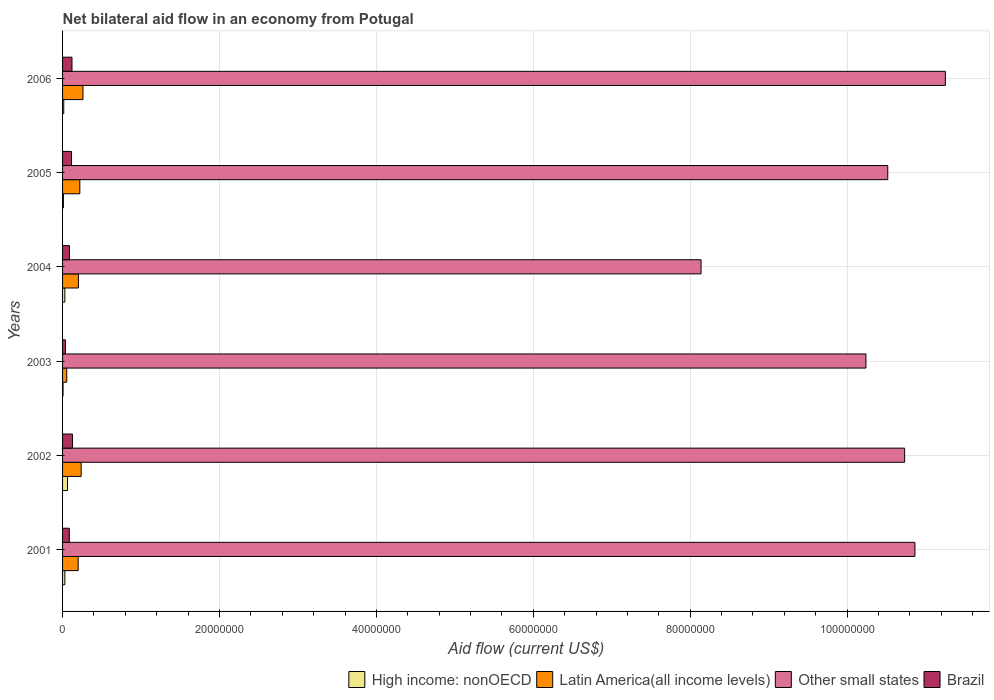Are the number of bars on each tick of the Y-axis equal?
Offer a very short reply. Yes. How many bars are there on the 4th tick from the top?
Offer a very short reply. 4. How many bars are there on the 3rd tick from the bottom?
Keep it short and to the point. 4. Across all years, what is the maximum net bilateral aid flow in Other small states?
Offer a terse response. 1.13e+08. Across all years, what is the minimum net bilateral aid flow in Other small states?
Offer a terse response. 8.14e+07. What is the total net bilateral aid flow in Brazil in the graph?
Ensure brevity in your answer.  5.72e+06. What is the difference between the net bilateral aid flow in Brazil in 2002 and that in 2005?
Your answer should be very brief. 1.30e+05. What is the difference between the net bilateral aid flow in Other small states in 2006 and the net bilateral aid flow in Latin America(all income levels) in 2005?
Offer a very short reply. 1.10e+08. What is the average net bilateral aid flow in Latin America(all income levels) per year?
Make the answer very short. 1.95e+06. In the year 2003, what is the difference between the net bilateral aid flow in High income: nonOECD and net bilateral aid flow in Latin America(all income levels)?
Offer a very short reply. -4.70e+05. In how many years, is the net bilateral aid flow in Other small states greater than 8000000 US$?
Provide a succinct answer. 6. What is the ratio of the net bilateral aid flow in High income: nonOECD in 2001 to that in 2002?
Make the answer very short. 0.46. Is the net bilateral aid flow in Latin America(all income levels) in 2003 less than that in 2006?
Your response must be concise. Yes. Is the difference between the net bilateral aid flow in High income: nonOECD in 2001 and 2002 greater than the difference between the net bilateral aid flow in Latin America(all income levels) in 2001 and 2002?
Your answer should be compact. Yes. What is the difference between the highest and the lowest net bilateral aid flow in High income: nonOECD?
Give a very brief answer. 5.70e+05. In how many years, is the net bilateral aid flow in Brazil greater than the average net bilateral aid flow in Brazil taken over all years?
Make the answer very short. 3. Is the sum of the net bilateral aid flow in Other small states in 2002 and 2006 greater than the maximum net bilateral aid flow in High income: nonOECD across all years?
Keep it short and to the point. Yes. What does the 3rd bar from the bottom in 2003 represents?
Offer a very short reply. Other small states. Is it the case that in every year, the sum of the net bilateral aid flow in Latin America(all income levels) and net bilateral aid flow in Brazil is greater than the net bilateral aid flow in Other small states?
Your answer should be very brief. No. Are all the bars in the graph horizontal?
Your response must be concise. Yes. How many years are there in the graph?
Give a very brief answer. 6. What is the difference between two consecutive major ticks on the X-axis?
Offer a very short reply. 2.00e+07. Where does the legend appear in the graph?
Your response must be concise. Bottom right. How are the legend labels stacked?
Offer a very short reply. Horizontal. What is the title of the graph?
Provide a short and direct response. Net bilateral aid flow in an economy from Potugal. Does "Mozambique" appear as one of the legend labels in the graph?
Your answer should be very brief. No. What is the label or title of the X-axis?
Ensure brevity in your answer.  Aid flow (current US$). What is the Aid flow (current US$) of Latin America(all income levels) in 2001?
Your answer should be very brief. 1.99e+06. What is the Aid flow (current US$) in Other small states in 2001?
Provide a succinct answer. 1.09e+08. What is the Aid flow (current US$) in Brazil in 2001?
Ensure brevity in your answer.  8.60e+05. What is the Aid flow (current US$) of High income: nonOECD in 2002?
Your answer should be compact. 6.30e+05. What is the Aid flow (current US$) in Latin America(all income levels) in 2002?
Give a very brief answer. 2.37e+06. What is the Aid flow (current US$) of Other small states in 2002?
Ensure brevity in your answer.  1.07e+08. What is the Aid flow (current US$) of Brazil in 2002?
Offer a very short reply. 1.27e+06. What is the Aid flow (current US$) in High income: nonOECD in 2003?
Provide a succinct answer. 6.00e+04. What is the Aid flow (current US$) of Latin America(all income levels) in 2003?
Provide a short and direct response. 5.30e+05. What is the Aid flow (current US$) in Other small states in 2003?
Give a very brief answer. 1.02e+08. What is the Aid flow (current US$) in High income: nonOECD in 2004?
Ensure brevity in your answer.  2.90e+05. What is the Aid flow (current US$) of Latin America(all income levels) in 2004?
Ensure brevity in your answer.  2.02e+06. What is the Aid flow (current US$) of Other small states in 2004?
Give a very brief answer. 8.14e+07. What is the Aid flow (current US$) of Brazil in 2004?
Offer a very short reply. 8.80e+05. What is the Aid flow (current US$) of Latin America(all income levels) in 2005?
Provide a succinct answer. 2.20e+06. What is the Aid flow (current US$) in Other small states in 2005?
Ensure brevity in your answer.  1.05e+08. What is the Aid flow (current US$) of Brazil in 2005?
Your answer should be compact. 1.14e+06. What is the Aid flow (current US$) in Latin America(all income levels) in 2006?
Give a very brief answer. 2.60e+06. What is the Aid flow (current US$) of Other small states in 2006?
Make the answer very short. 1.13e+08. What is the Aid flow (current US$) of Brazil in 2006?
Offer a terse response. 1.20e+06. Across all years, what is the maximum Aid flow (current US$) of High income: nonOECD?
Your response must be concise. 6.30e+05. Across all years, what is the maximum Aid flow (current US$) of Latin America(all income levels)?
Offer a terse response. 2.60e+06. Across all years, what is the maximum Aid flow (current US$) in Other small states?
Your answer should be compact. 1.13e+08. Across all years, what is the maximum Aid flow (current US$) of Brazil?
Give a very brief answer. 1.27e+06. Across all years, what is the minimum Aid flow (current US$) in Latin America(all income levels)?
Offer a terse response. 5.30e+05. Across all years, what is the minimum Aid flow (current US$) of Other small states?
Ensure brevity in your answer.  8.14e+07. What is the total Aid flow (current US$) of High income: nonOECD in the graph?
Ensure brevity in your answer.  1.53e+06. What is the total Aid flow (current US$) of Latin America(all income levels) in the graph?
Your answer should be very brief. 1.17e+07. What is the total Aid flow (current US$) of Other small states in the graph?
Provide a short and direct response. 6.17e+08. What is the total Aid flow (current US$) in Brazil in the graph?
Offer a terse response. 5.72e+06. What is the difference between the Aid flow (current US$) in Latin America(all income levels) in 2001 and that in 2002?
Give a very brief answer. -3.80e+05. What is the difference between the Aid flow (current US$) of Other small states in 2001 and that in 2002?
Keep it short and to the point. 1.31e+06. What is the difference between the Aid flow (current US$) of Brazil in 2001 and that in 2002?
Offer a terse response. -4.10e+05. What is the difference between the Aid flow (current US$) of Latin America(all income levels) in 2001 and that in 2003?
Your response must be concise. 1.46e+06. What is the difference between the Aid flow (current US$) of Other small states in 2001 and that in 2003?
Offer a terse response. 6.24e+06. What is the difference between the Aid flow (current US$) of Brazil in 2001 and that in 2003?
Your response must be concise. 4.90e+05. What is the difference between the Aid flow (current US$) in High income: nonOECD in 2001 and that in 2004?
Make the answer very short. 0. What is the difference between the Aid flow (current US$) of Other small states in 2001 and that in 2004?
Offer a very short reply. 2.73e+07. What is the difference between the Aid flow (current US$) in Other small states in 2001 and that in 2005?
Offer a terse response. 3.46e+06. What is the difference between the Aid flow (current US$) of Brazil in 2001 and that in 2005?
Provide a short and direct response. -2.80e+05. What is the difference between the Aid flow (current US$) of Latin America(all income levels) in 2001 and that in 2006?
Ensure brevity in your answer.  -6.10e+05. What is the difference between the Aid flow (current US$) of Other small states in 2001 and that in 2006?
Keep it short and to the point. -3.88e+06. What is the difference between the Aid flow (current US$) in Brazil in 2001 and that in 2006?
Provide a succinct answer. -3.40e+05. What is the difference between the Aid flow (current US$) in High income: nonOECD in 2002 and that in 2003?
Keep it short and to the point. 5.70e+05. What is the difference between the Aid flow (current US$) of Latin America(all income levels) in 2002 and that in 2003?
Provide a succinct answer. 1.84e+06. What is the difference between the Aid flow (current US$) in Other small states in 2002 and that in 2003?
Offer a terse response. 4.93e+06. What is the difference between the Aid flow (current US$) in High income: nonOECD in 2002 and that in 2004?
Keep it short and to the point. 3.40e+05. What is the difference between the Aid flow (current US$) of Other small states in 2002 and that in 2004?
Provide a short and direct response. 2.60e+07. What is the difference between the Aid flow (current US$) in High income: nonOECD in 2002 and that in 2005?
Ensure brevity in your answer.  5.20e+05. What is the difference between the Aid flow (current US$) in Latin America(all income levels) in 2002 and that in 2005?
Make the answer very short. 1.70e+05. What is the difference between the Aid flow (current US$) of Other small states in 2002 and that in 2005?
Offer a very short reply. 2.15e+06. What is the difference between the Aid flow (current US$) in Brazil in 2002 and that in 2005?
Provide a succinct answer. 1.30e+05. What is the difference between the Aid flow (current US$) in Other small states in 2002 and that in 2006?
Make the answer very short. -5.19e+06. What is the difference between the Aid flow (current US$) of Brazil in 2002 and that in 2006?
Offer a terse response. 7.00e+04. What is the difference between the Aid flow (current US$) in Latin America(all income levels) in 2003 and that in 2004?
Your answer should be very brief. -1.49e+06. What is the difference between the Aid flow (current US$) of Other small states in 2003 and that in 2004?
Your response must be concise. 2.10e+07. What is the difference between the Aid flow (current US$) in Brazil in 2003 and that in 2004?
Ensure brevity in your answer.  -5.10e+05. What is the difference between the Aid flow (current US$) of High income: nonOECD in 2003 and that in 2005?
Your answer should be compact. -5.00e+04. What is the difference between the Aid flow (current US$) of Latin America(all income levels) in 2003 and that in 2005?
Keep it short and to the point. -1.67e+06. What is the difference between the Aid flow (current US$) in Other small states in 2003 and that in 2005?
Provide a succinct answer. -2.78e+06. What is the difference between the Aid flow (current US$) of Brazil in 2003 and that in 2005?
Your response must be concise. -7.70e+05. What is the difference between the Aid flow (current US$) in Latin America(all income levels) in 2003 and that in 2006?
Your answer should be very brief. -2.07e+06. What is the difference between the Aid flow (current US$) of Other small states in 2003 and that in 2006?
Keep it short and to the point. -1.01e+07. What is the difference between the Aid flow (current US$) of Brazil in 2003 and that in 2006?
Your response must be concise. -8.30e+05. What is the difference between the Aid flow (current US$) in High income: nonOECD in 2004 and that in 2005?
Your answer should be very brief. 1.80e+05. What is the difference between the Aid flow (current US$) of Latin America(all income levels) in 2004 and that in 2005?
Make the answer very short. -1.80e+05. What is the difference between the Aid flow (current US$) of Other small states in 2004 and that in 2005?
Make the answer very short. -2.38e+07. What is the difference between the Aid flow (current US$) in Brazil in 2004 and that in 2005?
Keep it short and to the point. -2.60e+05. What is the difference between the Aid flow (current US$) of Latin America(all income levels) in 2004 and that in 2006?
Offer a very short reply. -5.80e+05. What is the difference between the Aid flow (current US$) of Other small states in 2004 and that in 2006?
Provide a short and direct response. -3.11e+07. What is the difference between the Aid flow (current US$) in Brazil in 2004 and that in 2006?
Offer a very short reply. -3.20e+05. What is the difference between the Aid flow (current US$) of Latin America(all income levels) in 2005 and that in 2006?
Make the answer very short. -4.00e+05. What is the difference between the Aid flow (current US$) of Other small states in 2005 and that in 2006?
Your answer should be compact. -7.34e+06. What is the difference between the Aid flow (current US$) of High income: nonOECD in 2001 and the Aid flow (current US$) of Latin America(all income levels) in 2002?
Provide a short and direct response. -2.08e+06. What is the difference between the Aid flow (current US$) of High income: nonOECD in 2001 and the Aid flow (current US$) of Other small states in 2002?
Your answer should be compact. -1.07e+08. What is the difference between the Aid flow (current US$) in High income: nonOECD in 2001 and the Aid flow (current US$) in Brazil in 2002?
Provide a short and direct response. -9.80e+05. What is the difference between the Aid flow (current US$) of Latin America(all income levels) in 2001 and the Aid flow (current US$) of Other small states in 2002?
Provide a succinct answer. -1.05e+08. What is the difference between the Aid flow (current US$) of Latin America(all income levels) in 2001 and the Aid flow (current US$) of Brazil in 2002?
Keep it short and to the point. 7.20e+05. What is the difference between the Aid flow (current US$) in Other small states in 2001 and the Aid flow (current US$) in Brazil in 2002?
Ensure brevity in your answer.  1.07e+08. What is the difference between the Aid flow (current US$) of High income: nonOECD in 2001 and the Aid flow (current US$) of Other small states in 2003?
Provide a succinct answer. -1.02e+08. What is the difference between the Aid flow (current US$) in Latin America(all income levels) in 2001 and the Aid flow (current US$) in Other small states in 2003?
Your response must be concise. -1.00e+08. What is the difference between the Aid flow (current US$) of Latin America(all income levels) in 2001 and the Aid flow (current US$) of Brazil in 2003?
Offer a terse response. 1.62e+06. What is the difference between the Aid flow (current US$) of Other small states in 2001 and the Aid flow (current US$) of Brazil in 2003?
Keep it short and to the point. 1.08e+08. What is the difference between the Aid flow (current US$) of High income: nonOECD in 2001 and the Aid flow (current US$) of Latin America(all income levels) in 2004?
Keep it short and to the point. -1.73e+06. What is the difference between the Aid flow (current US$) of High income: nonOECD in 2001 and the Aid flow (current US$) of Other small states in 2004?
Your answer should be very brief. -8.11e+07. What is the difference between the Aid flow (current US$) of High income: nonOECD in 2001 and the Aid flow (current US$) of Brazil in 2004?
Offer a terse response. -5.90e+05. What is the difference between the Aid flow (current US$) of Latin America(all income levels) in 2001 and the Aid flow (current US$) of Other small states in 2004?
Give a very brief answer. -7.94e+07. What is the difference between the Aid flow (current US$) in Latin America(all income levels) in 2001 and the Aid flow (current US$) in Brazil in 2004?
Provide a short and direct response. 1.11e+06. What is the difference between the Aid flow (current US$) in Other small states in 2001 and the Aid flow (current US$) in Brazil in 2004?
Your answer should be very brief. 1.08e+08. What is the difference between the Aid flow (current US$) of High income: nonOECD in 2001 and the Aid flow (current US$) of Latin America(all income levels) in 2005?
Your answer should be very brief. -1.91e+06. What is the difference between the Aid flow (current US$) of High income: nonOECD in 2001 and the Aid flow (current US$) of Other small states in 2005?
Your answer should be very brief. -1.05e+08. What is the difference between the Aid flow (current US$) of High income: nonOECD in 2001 and the Aid flow (current US$) of Brazil in 2005?
Offer a terse response. -8.50e+05. What is the difference between the Aid flow (current US$) in Latin America(all income levels) in 2001 and the Aid flow (current US$) in Other small states in 2005?
Provide a short and direct response. -1.03e+08. What is the difference between the Aid flow (current US$) in Latin America(all income levels) in 2001 and the Aid flow (current US$) in Brazil in 2005?
Provide a short and direct response. 8.50e+05. What is the difference between the Aid flow (current US$) of Other small states in 2001 and the Aid flow (current US$) of Brazil in 2005?
Provide a short and direct response. 1.08e+08. What is the difference between the Aid flow (current US$) of High income: nonOECD in 2001 and the Aid flow (current US$) of Latin America(all income levels) in 2006?
Keep it short and to the point. -2.31e+06. What is the difference between the Aid flow (current US$) of High income: nonOECD in 2001 and the Aid flow (current US$) of Other small states in 2006?
Provide a short and direct response. -1.12e+08. What is the difference between the Aid flow (current US$) in High income: nonOECD in 2001 and the Aid flow (current US$) in Brazil in 2006?
Provide a short and direct response. -9.10e+05. What is the difference between the Aid flow (current US$) in Latin America(all income levels) in 2001 and the Aid flow (current US$) in Other small states in 2006?
Provide a succinct answer. -1.11e+08. What is the difference between the Aid flow (current US$) in Latin America(all income levels) in 2001 and the Aid flow (current US$) in Brazil in 2006?
Offer a terse response. 7.90e+05. What is the difference between the Aid flow (current US$) of Other small states in 2001 and the Aid flow (current US$) of Brazil in 2006?
Make the answer very short. 1.07e+08. What is the difference between the Aid flow (current US$) in High income: nonOECD in 2002 and the Aid flow (current US$) in Latin America(all income levels) in 2003?
Your response must be concise. 1.00e+05. What is the difference between the Aid flow (current US$) in High income: nonOECD in 2002 and the Aid flow (current US$) in Other small states in 2003?
Your answer should be very brief. -1.02e+08. What is the difference between the Aid flow (current US$) of High income: nonOECD in 2002 and the Aid flow (current US$) of Brazil in 2003?
Ensure brevity in your answer.  2.60e+05. What is the difference between the Aid flow (current US$) of Latin America(all income levels) in 2002 and the Aid flow (current US$) of Other small states in 2003?
Your answer should be compact. -1.00e+08. What is the difference between the Aid flow (current US$) in Other small states in 2002 and the Aid flow (current US$) in Brazil in 2003?
Your response must be concise. 1.07e+08. What is the difference between the Aid flow (current US$) in High income: nonOECD in 2002 and the Aid flow (current US$) in Latin America(all income levels) in 2004?
Keep it short and to the point. -1.39e+06. What is the difference between the Aid flow (current US$) of High income: nonOECD in 2002 and the Aid flow (current US$) of Other small states in 2004?
Keep it short and to the point. -8.08e+07. What is the difference between the Aid flow (current US$) of High income: nonOECD in 2002 and the Aid flow (current US$) of Brazil in 2004?
Provide a succinct answer. -2.50e+05. What is the difference between the Aid flow (current US$) of Latin America(all income levels) in 2002 and the Aid flow (current US$) of Other small states in 2004?
Offer a very short reply. -7.90e+07. What is the difference between the Aid flow (current US$) of Latin America(all income levels) in 2002 and the Aid flow (current US$) of Brazil in 2004?
Offer a terse response. 1.49e+06. What is the difference between the Aid flow (current US$) of Other small states in 2002 and the Aid flow (current US$) of Brazil in 2004?
Make the answer very short. 1.06e+08. What is the difference between the Aid flow (current US$) of High income: nonOECD in 2002 and the Aid flow (current US$) of Latin America(all income levels) in 2005?
Give a very brief answer. -1.57e+06. What is the difference between the Aid flow (current US$) in High income: nonOECD in 2002 and the Aid flow (current US$) in Other small states in 2005?
Ensure brevity in your answer.  -1.05e+08. What is the difference between the Aid flow (current US$) of High income: nonOECD in 2002 and the Aid flow (current US$) of Brazil in 2005?
Your answer should be very brief. -5.10e+05. What is the difference between the Aid flow (current US$) in Latin America(all income levels) in 2002 and the Aid flow (current US$) in Other small states in 2005?
Provide a succinct answer. -1.03e+08. What is the difference between the Aid flow (current US$) in Latin America(all income levels) in 2002 and the Aid flow (current US$) in Brazil in 2005?
Your answer should be compact. 1.23e+06. What is the difference between the Aid flow (current US$) of Other small states in 2002 and the Aid flow (current US$) of Brazil in 2005?
Your response must be concise. 1.06e+08. What is the difference between the Aid flow (current US$) in High income: nonOECD in 2002 and the Aid flow (current US$) in Latin America(all income levels) in 2006?
Offer a terse response. -1.97e+06. What is the difference between the Aid flow (current US$) in High income: nonOECD in 2002 and the Aid flow (current US$) in Other small states in 2006?
Ensure brevity in your answer.  -1.12e+08. What is the difference between the Aid flow (current US$) in High income: nonOECD in 2002 and the Aid flow (current US$) in Brazil in 2006?
Offer a very short reply. -5.70e+05. What is the difference between the Aid flow (current US$) in Latin America(all income levels) in 2002 and the Aid flow (current US$) in Other small states in 2006?
Make the answer very short. -1.10e+08. What is the difference between the Aid flow (current US$) in Latin America(all income levels) in 2002 and the Aid flow (current US$) in Brazil in 2006?
Offer a terse response. 1.17e+06. What is the difference between the Aid flow (current US$) of Other small states in 2002 and the Aid flow (current US$) of Brazil in 2006?
Offer a terse response. 1.06e+08. What is the difference between the Aid flow (current US$) in High income: nonOECD in 2003 and the Aid flow (current US$) in Latin America(all income levels) in 2004?
Offer a terse response. -1.96e+06. What is the difference between the Aid flow (current US$) of High income: nonOECD in 2003 and the Aid flow (current US$) of Other small states in 2004?
Provide a succinct answer. -8.13e+07. What is the difference between the Aid flow (current US$) in High income: nonOECD in 2003 and the Aid flow (current US$) in Brazil in 2004?
Your answer should be very brief. -8.20e+05. What is the difference between the Aid flow (current US$) in Latin America(all income levels) in 2003 and the Aid flow (current US$) in Other small states in 2004?
Ensure brevity in your answer.  -8.08e+07. What is the difference between the Aid flow (current US$) of Latin America(all income levels) in 2003 and the Aid flow (current US$) of Brazil in 2004?
Make the answer very short. -3.50e+05. What is the difference between the Aid flow (current US$) in Other small states in 2003 and the Aid flow (current US$) in Brazil in 2004?
Keep it short and to the point. 1.02e+08. What is the difference between the Aid flow (current US$) in High income: nonOECD in 2003 and the Aid flow (current US$) in Latin America(all income levels) in 2005?
Offer a very short reply. -2.14e+06. What is the difference between the Aid flow (current US$) in High income: nonOECD in 2003 and the Aid flow (current US$) in Other small states in 2005?
Provide a short and direct response. -1.05e+08. What is the difference between the Aid flow (current US$) of High income: nonOECD in 2003 and the Aid flow (current US$) of Brazil in 2005?
Offer a very short reply. -1.08e+06. What is the difference between the Aid flow (current US$) in Latin America(all income levels) in 2003 and the Aid flow (current US$) in Other small states in 2005?
Offer a very short reply. -1.05e+08. What is the difference between the Aid flow (current US$) of Latin America(all income levels) in 2003 and the Aid flow (current US$) of Brazil in 2005?
Provide a succinct answer. -6.10e+05. What is the difference between the Aid flow (current US$) in Other small states in 2003 and the Aid flow (current US$) in Brazil in 2005?
Ensure brevity in your answer.  1.01e+08. What is the difference between the Aid flow (current US$) in High income: nonOECD in 2003 and the Aid flow (current US$) in Latin America(all income levels) in 2006?
Your response must be concise. -2.54e+06. What is the difference between the Aid flow (current US$) in High income: nonOECD in 2003 and the Aid flow (current US$) in Other small states in 2006?
Make the answer very short. -1.12e+08. What is the difference between the Aid flow (current US$) of High income: nonOECD in 2003 and the Aid flow (current US$) of Brazil in 2006?
Make the answer very short. -1.14e+06. What is the difference between the Aid flow (current US$) in Latin America(all income levels) in 2003 and the Aid flow (current US$) in Other small states in 2006?
Offer a terse response. -1.12e+08. What is the difference between the Aid flow (current US$) in Latin America(all income levels) in 2003 and the Aid flow (current US$) in Brazil in 2006?
Your answer should be compact. -6.70e+05. What is the difference between the Aid flow (current US$) in Other small states in 2003 and the Aid flow (current US$) in Brazil in 2006?
Offer a terse response. 1.01e+08. What is the difference between the Aid flow (current US$) of High income: nonOECD in 2004 and the Aid flow (current US$) of Latin America(all income levels) in 2005?
Your answer should be compact. -1.91e+06. What is the difference between the Aid flow (current US$) of High income: nonOECD in 2004 and the Aid flow (current US$) of Other small states in 2005?
Your answer should be very brief. -1.05e+08. What is the difference between the Aid flow (current US$) of High income: nonOECD in 2004 and the Aid flow (current US$) of Brazil in 2005?
Your answer should be very brief. -8.50e+05. What is the difference between the Aid flow (current US$) of Latin America(all income levels) in 2004 and the Aid flow (current US$) of Other small states in 2005?
Your response must be concise. -1.03e+08. What is the difference between the Aid flow (current US$) of Latin America(all income levels) in 2004 and the Aid flow (current US$) of Brazil in 2005?
Your answer should be compact. 8.80e+05. What is the difference between the Aid flow (current US$) of Other small states in 2004 and the Aid flow (current US$) of Brazil in 2005?
Make the answer very short. 8.02e+07. What is the difference between the Aid flow (current US$) of High income: nonOECD in 2004 and the Aid flow (current US$) of Latin America(all income levels) in 2006?
Give a very brief answer. -2.31e+06. What is the difference between the Aid flow (current US$) in High income: nonOECD in 2004 and the Aid flow (current US$) in Other small states in 2006?
Make the answer very short. -1.12e+08. What is the difference between the Aid flow (current US$) in High income: nonOECD in 2004 and the Aid flow (current US$) in Brazil in 2006?
Provide a succinct answer. -9.10e+05. What is the difference between the Aid flow (current US$) in Latin America(all income levels) in 2004 and the Aid flow (current US$) in Other small states in 2006?
Ensure brevity in your answer.  -1.10e+08. What is the difference between the Aid flow (current US$) in Latin America(all income levels) in 2004 and the Aid flow (current US$) in Brazil in 2006?
Your answer should be very brief. 8.20e+05. What is the difference between the Aid flow (current US$) of Other small states in 2004 and the Aid flow (current US$) of Brazil in 2006?
Offer a very short reply. 8.02e+07. What is the difference between the Aid flow (current US$) in High income: nonOECD in 2005 and the Aid flow (current US$) in Latin America(all income levels) in 2006?
Offer a terse response. -2.49e+06. What is the difference between the Aid flow (current US$) of High income: nonOECD in 2005 and the Aid flow (current US$) of Other small states in 2006?
Make the answer very short. -1.12e+08. What is the difference between the Aid flow (current US$) of High income: nonOECD in 2005 and the Aid flow (current US$) of Brazil in 2006?
Your response must be concise. -1.09e+06. What is the difference between the Aid flow (current US$) in Latin America(all income levels) in 2005 and the Aid flow (current US$) in Other small states in 2006?
Your answer should be very brief. -1.10e+08. What is the difference between the Aid flow (current US$) in Latin America(all income levels) in 2005 and the Aid flow (current US$) in Brazil in 2006?
Ensure brevity in your answer.  1.00e+06. What is the difference between the Aid flow (current US$) in Other small states in 2005 and the Aid flow (current US$) in Brazil in 2006?
Make the answer very short. 1.04e+08. What is the average Aid flow (current US$) of High income: nonOECD per year?
Offer a very short reply. 2.55e+05. What is the average Aid flow (current US$) in Latin America(all income levels) per year?
Make the answer very short. 1.95e+06. What is the average Aid flow (current US$) in Other small states per year?
Keep it short and to the point. 1.03e+08. What is the average Aid flow (current US$) of Brazil per year?
Offer a very short reply. 9.53e+05. In the year 2001, what is the difference between the Aid flow (current US$) of High income: nonOECD and Aid flow (current US$) of Latin America(all income levels)?
Give a very brief answer. -1.70e+06. In the year 2001, what is the difference between the Aid flow (current US$) in High income: nonOECD and Aid flow (current US$) in Other small states?
Your answer should be compact. -1.08e+08. In the year 2001, what is the difference between the Aid flow (current US$) in High income: nonOECD and Aid flow (current US$) in Brazil?
Ensure brevity in your answer.  -5.70e+05. In the year 2001, what is the difference between the Aid flow (current US$) of Latin America(all income levels) and Aid flow (current US$) of Other small states?
Your response must be concise. -1.07e+08. In the year 2001, what is the difference between the Aid flow (current US$) of Latin America(all income levels) and Aid flow (current US$) of Brazil?
Give a very brief answer. 1.13e+06. In the year 2001, what is the difference between the Aid flow (current US$) in Other small states and Aid flow (current US$) in Brazil?
Ensure brevity in your answer.  1.08e+08. In the year 2002, what is the difference between the Aid flow (current US$) in High income: nonOECD and Aid flow (current US$) in Latin America(all income levels)?
Your answer should be compact. -1.74e+06. In the year 2002, what is the difference between the Aid flow (current US$) of High income: nonOECD and Aid flow (current US$) of Other small states?
Offer a very short reply. -1.07e+08. In the year 2002, what is the difference between the Aid flow (current US$) in High income: nonOECD and Aid flow (current US$) in Brazil?
Offer a very short reply. -6.40e+05. In the year 2002, what is the difference between the Aid flow (current US$) in Latin America(all income levels) and Aid flow (current US$) in Other small states?
Your answer should be compact. -1.05e+08. In the year 2002, what is the difference between the Aid flow (current US$) of Latin America(all income levels) and Aid flow (current US$) of Brazil?
Your answer should be very brief. 1.10e+06. In the year 2002, what is the difference between the Aid flow (current US$) in Other small states and Aid flow (current US$) in Brazil?
Offer a terse response. 1.06e+08. In the year 2003, what is the difference between the Aid flow (current US$) in High income: nonOECD and Aid flow (current US$) in Latin America(all income levels)?
Offer a very short reply. -4.70e+05. In the year 2003, what is the difference between the Aid flow (current US$) in High income: nonOECD and Aid flow (current US$) in Other small states?
Make the answer very short. -1.02e+08. In the year 2003, what is the difference between the Aid flow (current US$) in High income: nonOECD and Aid flow (current US$) in Brazil?
Your answer should be very brief. -3.10e+05. In the year 2003, what is the difference between the Aid flow (current US$) of Latin America(all income levels) and Aid flow (current US$) of Other small states?
Offer a terse response. -1.02e+08. In the year 2003, what is the difference between the Aid flow (current US$) in Other small states and Aid flow (current US$) in Brazil?
Ensure brevity in your answer.  1.02e+08. In the year 2004, what is the difference between the Aid flow (current US$) in High income: nonOECD and Aid flow (current US$) in Latin America(all income levels)?
Give a very brief answer. -1.73e+06. In the year 2004, what is the difference between the Aid flow (current US$) in High income: nonOECD and Aid flow (current US$) in Other small states?
Your answer should be very brief. -8.11e+07. In the year 2004, what is the difference between the Aid flow (current US$) of High income: nonOECD and Aid flow (current US$) of Brazil?
Offer a terse response. -5.90e+05. In the year 2004, what is the difference between the Aid flow (current US$) in Latin America(all income levels) and Aid flow (current US$) in Other small states?
Offer a terse response. -7.94e+07. In the year 2004, what is the difference between the Aid flow (current US$) in Latin America(all income levels) and Aid flow (current US$) in Brazil?
Provide a short and direct response. 1.14e+06. In the year 2004, what is the difference between the Aid flow (current US$) in Other small states and Aid flow (current US$) in Brazil?
Provide a short and direct response. 8.05e+07. In the year 2005, what is the difference between the Aid flow (current US$) of High income: nonOECD and Aid flow (current US$) of Latin America(all income levels)?
Your answer should be very brief. -2.09e+06. In the year 2005, what is the difference between the Aid flow (current US$) in High income: nonOECD and Aid flow (current US$) in Other small states?
Your answer should be very brief. -1.05e+08. In the year 2005, what is the difference between the Aid flow (current US$) in High income: nonOECD and Aid flow (current US$) in Brazil?
Your answer should be compact. -1.03e+06. In the year 2005, what is the difference between the Aid flow (current US$) in Latin America(all income levels) and Aid flow (current US$) in Other small states?
Your answer should be compact. -1.03e+08. In the year 2005, what is the difference between the Aid flow (current US$) of Latin America(all income levels) and Aid flow (current US$) of Brazil?
Your answer should be compact. 1.06e+06. In the year 2005, what is the difference between the Aid flow (current US$) of Other small states and Aid flow (current US$) of Brazil?
Make the answer very short. 1.04e+08. In the year 2006, what is the difference between the Aid flow (current US$) of High income: nonOECD and Aid flow (current US$) of Latin America(all income levels)?
Your response must be concise. -2.45e+06. In the year 2006, what is the difference between the Aid flow (current US$) of High income: nonOECD and Aid flow (current US$) of Other small states?
Your answer should be very brief. -1.12e+08. In the year 2006, what is the difference between the Aid flow (current US$) in High income: nonOECD and Aid flow (current US$) in Brazil?
Keep it short and to the point. -1.05e+06. In the year 2006, what is the difference between the Aid flow (current US$) of Latin America(all income levels) and Aid flow (current US$) of Other small states?
Make the answer very short. -1.10e+08. In the year 2006, what is the difference between the Aid flow (current US$) in Latin America(all income levels) and Aid flow (current US$) in Brazil?
Keep it short and to the point. 1.40e+06. In the year 2006, what is the difference between the Aid flow (current US$) of Other small states and Aid flow (current US$) of Brazil?
Your answer should be very brief. 1.11e+08. What is the ratio of the Aid flow (current US$) in High income: nonOECD in 2001 to that in 2002?
Offer a terse response. 0.46. What is the ratio of the Aid flow (current US$) in Latin America(all income levels) in 2001 to that in 2002?
Keep it short and to the point. 0.84. What is the ratio of the Aid flow (current US$) in Other small states in 2001 to that in 2002?
Your response must be concise. 1.01. What is the ratio of the Aid flow (current US$) in Brazil in 2001 to that in 2002?
Your answer should be very brief. 0.68. What is the ratio of the Aid flow (current US$) in High income: nonOECD in 2001 to that in 2003?
Ensure brevity in your answer.  4.83. What is the ratio of the Aid flow (current US$) in Latin America(all income levels) in 2001 to that in 2003?
Provide a short and direct response. 3.75. What is the ratio of the Aid flow (current US$) of Other small states in 2001 to that in 2003?
Keep it short and to the point. 1.06. What is the ratio of the Aid flow (current US$) of Brazil in 2001 to that in 2003?
Your answer should be very brief. 2.32. What is the ratio of the Aid flow (current US$) of High income: nonOECD in 2001 to that in 2004?
Your answer should be compact. 1. What is the ratio of the Aid flow (current US$) of Latin America(all income levels) in 2001 to that in 2004?
Make the answer very short. 0.99. What is the ratio of the Aid flow (current US$) in Other small states in 2001 to that in 2004?
Provide a succinct answer. 1.33. What is the ratio of the Aid flow (current US$) of Brazil in 2001 to that in 2004?
Your response must be concise. 0.98. What is the ratio of the Aid flow (current US$) in High income: nonOECD in 2001 to that in 2005?
Offer a terse response. 2.64. What is the ratio of the Aid flow (current US$) of Latin America(all income levels) in 2001 to that in 2005?
Your response must be concise. 0.9. What is the ratio of the Aid flow (current US$) in Other small states in 2001 to that in 2005?
Your answer should be compact. 1.03. What is the ratio of the Aid flow (current US$) of Brazil in 2001 to that in 2005?
Offer a very short reply. 0.75. What is the ratio of the Aid flow (current US$) of High income: nonOECD in 2001 to that in 2006?
Give a very brief answer. 1.93. What is the ratio of the Aid flow (current US$) in Latin America(all income levels) in 2001 to that in 2006?
Your answer should be compact. 0.77. What is the ratio of the Aid flow (current US$) in Other small states in 2001 to that in 2006?
Make the answer very short. 0.97. What is the ratio of the Aid flow (current US$) in Brazil in 2001 to that in 2006?
Give a very brief answer. 0.72. What is the ratio of the Aid flow (current US$) of Latin America(all income levels) in 2002 to that in 2003?
Keep it short and to the point. 4.47. What is the ratio of the Aid flow (current US$) in Other small states in 2002 to that in 2003?
Your answer should be compact. 1.05. What is the ratio of the Aid flow (current US$) in Brazil in 2002 to that in 2003?
Your answer should be very brief. 3.43. What is the ratio of the Aid flow (current US$) in High income: nonOECD in 2002 to that in 2004?
Keep it short and to the point. 2.17. What is the ratio of the Aid flow (current US$) in Latin America(all income levels) in 2002 to that in 2004?
Your response must be concise. 1.17. What is the ratio of the Aid flow (current US$) in Other small states in 2002 to that in 2004?
Ensure brevity in your answer.  1.32. What is the ratio of the Aid flow (current US$) in Brazil in 2002 to that in 2004?
Your response must be concise. 1.44. What is the ratio of the Aid flow (current US$) of High income: nonOECD in 2002 to that in 2005?
Your answer should be compact. 5.73. What is the ratio of the Aid flow (current US$) of Latin America(all income levels) in 2002 to that in 2005?
Offer a terse response. 1.08. What is the ratio of the Aid flow (current US$) of Other small states in 2002 to that in 2005?
Provide a succinct answer. 1.02. What is the ratio of the Aid flow (current US$) in Brazil in 2002 to that in 2005?
Ensure brevity in your answer.  1.11. What is the ratio of the Aid flow (current US$) in High income: nonOECD in 2002 to that in 2006?
Offer a terse response. 4.2. What is the ratio of the Aid flow (current US$) in Latin America(all income levels) in 2002 to that in 2006?
Provide a succinct answer. 0.91. What is the ratio of the Aid flow (current US$) in Other small states in 2002 to that in 2006?
Ensure brevity in your answer.  0.95. What is the ratio of the Aid flow (current US$) of Brazil in 2002 to that in 2006?
Provide a short and direct response. 1.06. What is the ratio of the Aid flow (current US$) in High income: nonOECD in 2003 to that in 2004?
Make the answer very short. 0.21. What is the ratio of the Aid flow (current US$) of Latin America(all income levels) in 2003 to that in 2004?
Keep it short and to the point. 0.26. What is the ratio of the Aid flow (current US$) of Other small states in 2003 to that in 2004?
Your answer should be very brief. 1.26. What is the ratio of the Aid flow (current US$) of Brazil in 2003 to that in 2004?
Your response must be concise. 0.42. What is the ratio of the Aid flow (current US$) of High income: nonOECD in 2003 to that in 2005?
Ensure brevity in your answer.  0.55. What is the ratio of the Aid flow (current US$) of Latin America(all income levels) in 2003 to that in 2005?
Offer a terse response. 0.24. What is the ratio of the Aid flow (current US$) of Other small states in 2003 to that in 2005?
Keep it short and to the point. 0.97. What is the ratio of the Aid flow (current US$) of Brazil in 2003 to that in 2005?
Offer a very short reply. 0.32. What is the ratio of the Aid flow (current US$) in Latin America(all income levels) in 2003 to that in 2006?
Give a very brief answer. 0.2. What is the ratio of the Aid flow (current US$) in Other small states in 2003 to that in 2006?
Your answer should be compact. 0.91. What is the ratio of the Aid flow (current US$) of Brazil in 2003 to that in 2006?
Ensure brevity in your answer.  0.31. What is the ratio of the Aid flow (current US$) in High income: nonOECD in 2004 to that in 2005?
Provide a succinct answer. 2.64. What is the ratio of the Aid flow (current US$) of Latin America(all income levels) in 2004 to that in 2005?
Offer a very short reply. 0.92. What is the ratio of the Aid flow (current US$) of Other small states in 2004 to that in 2005?
Give a very brief answer. 0.77. What is the ratio of the Aid flow (current US$) of Brazil in 2004 to that in 2005?
Provide a succinct answer. 0.77. What is the ratio of the Aid flow (current US$) in High income: nonOECD in 2004 to that in 2006?
Provide a succinct answer. 1.93. What is the ratio of the Aid flow (current US$) of Latin America(all income levels) in 2004 to that in 2006?
Your answer should be compact. 0.78. What is the ratio of the Aid flow (current US$) in Other small states in 2004 to that in 2006?
Ensure brevity in your answer.  0.72. What is the ratio of the Aid flow (current US$) of Brazil in 2004 to that in 2006?
Your answer should be compact. 0.73. What is the ratio of the Aid flow (current US$) of High income: nonOECD in 2005 to that in 2006?
Keep it short and to the point. 0.73. What is the ratio of the Aid flow (current US$) of Latin America(all income levels) in 2005 to that in 2006?
Provide a succinct answer. 0.85. What is the ratio of the Aid flow (current US$) of Other small states in 2005 to that in 2006?
Provide a short and direct response. 0.93. What is the difference between the highest and the second highest Aid flow (current US$) in Latin America(all income levels)?
Your answer should be compact. 2.30e+05. What is the difference between the highest and the second highest Aid flow (current US$) of Other small states?
Your answer should be compact. 3.88e+06. What is the difference between the highest and the second highest Aid flow (current US$) of Brazil?
Provide a short and direct response. 7.00e+04. What is the difference between the highest and the lowest Aid flow (current US$) in High income: nonOECD?
Provide a succinct answer. 5.70e+05. What is the difference between the highest and the lowest Aid flow (current US$) in Latin America(all income levels)?
Offer a very short reply. 2.07e+06. What is the difference between the highest and the lowest Aid flow (current US$) of Other small states?
Provide a succinct answer. 3.11e+07. What is the difference between the highest and the lowest Aid flow (current US$) in Brazil?
Provide a succinct answer. 9.00e+05. 